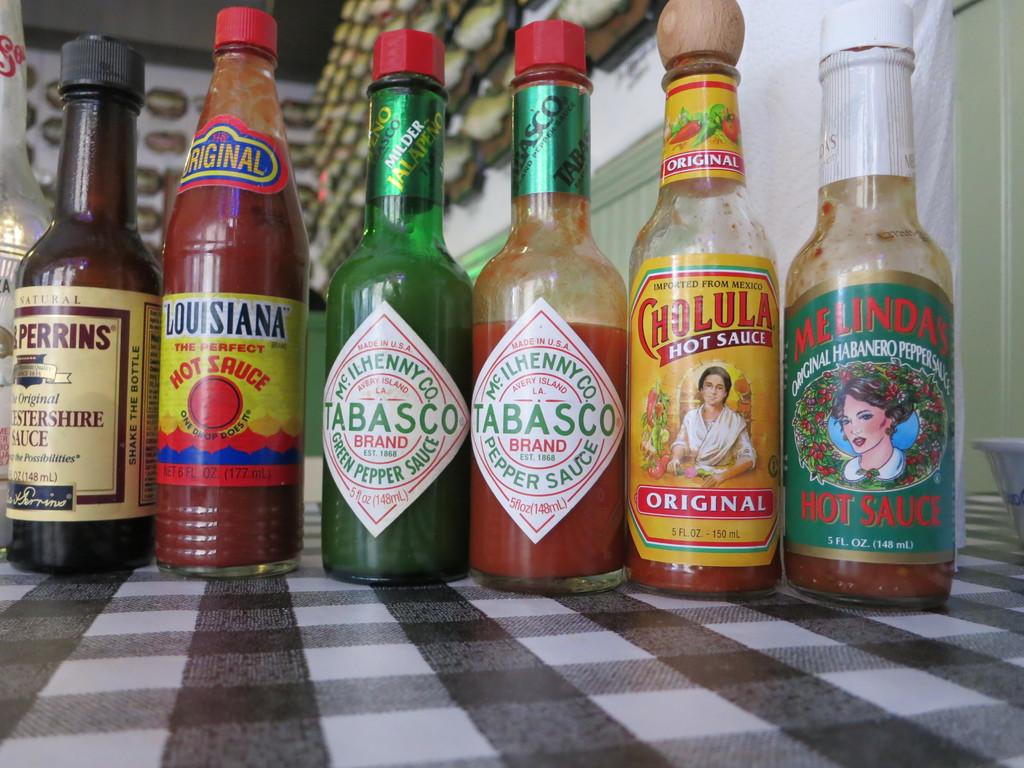What brand is the hot sauce with the green bottle?
Your answer should be compact. Tabasco. What brand of hot sauce is there more than one type of here?
Provide a succinct answer. Tabasco. 